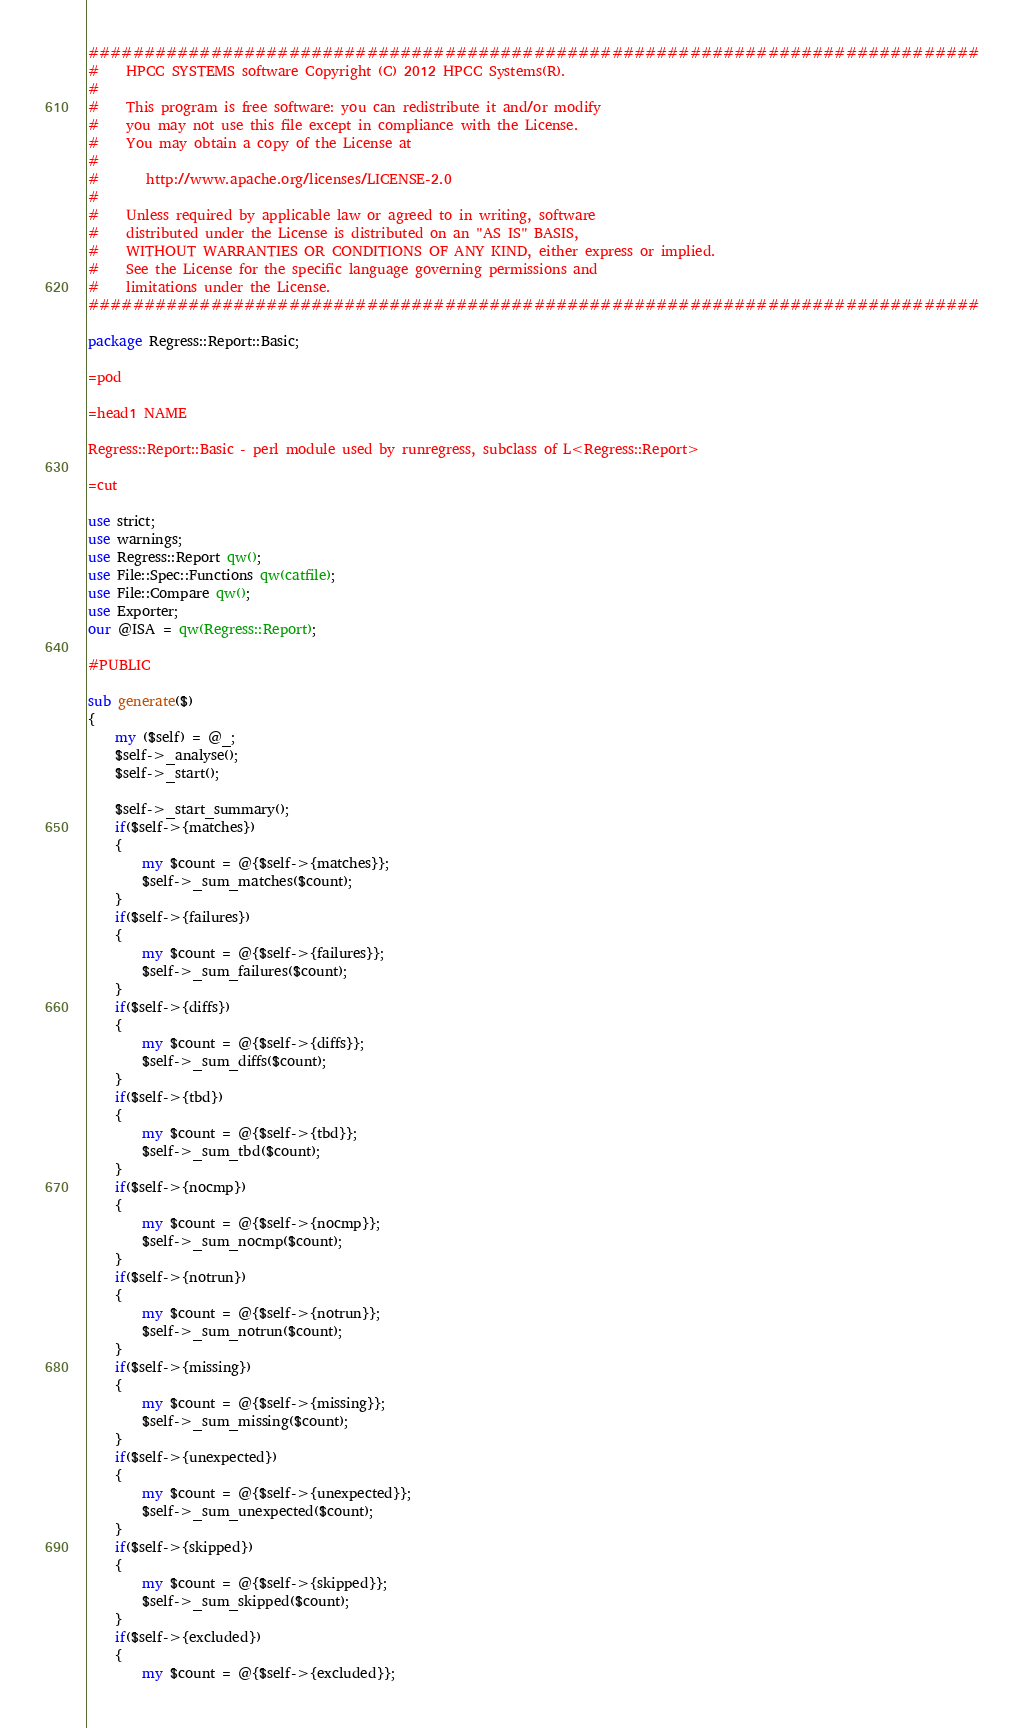<code> <loc_0><loc_0><loc_500><loc_500><_Perl_>################################################################################
#    HPCC SYSTEMS software Copyright (C) 2012 HPCC Systems(R).
#
#    This program is free software: you can redistribute it and/or modify
#    you may not use this file except in compliance with the License.
#    You may obtain a copy of the License at
#
#       http://www.apache.org/licenses/LICENSE-2.0
#
#    Unless required by applicable law or agreed to in writing, software
#    distributed under the License is distributed on an "AS IS" BASIS,
#    WITHOUT WARRANTIES OR CONDITIONS OF ANY KIND, either express or implied.
#    See the License for the specific language governing permissions and
#    limitations under the License.
################################################################################

package Regress::Report::Basic;

=pod

=head1 NAME
    
Regress::Report::Basic - perl module used by runregress, subclass of L<Regress::Report>

=cut

use strict;
use warnings;
use Regress::Report qw();
use File::Spec::Functions qw(catfile);
use File::Compare qw();
use Exporter;
our @ISA = qw(Regress::Report);

#PUBLIC

sub generate($)
{
    my ($self) = @_;
    $self->_analyse();
    $self->_start();

    $self->_start_summary();
    if($self->{matches})
    {
        my $count = @{$self->{matches}};
        $self->_sum_matches($count);
    }
    if($self->{failures})
    {
        my $count = @{$self->{failures}};
        $self->_sum_failures($count);
    }
    if($self->{diffs})
    {
        my $count = @{$self->{diffs}};
        $self->_sum_diffs($count);
    }
    if($self->{tbd})
    {
        my $count = @{$self->{tbd}};
        $self->_sum_tbd($count);
    }
    if($self->{nocmp})
    {
        my $count = @{$self->{nocmp}};
        $self->_sum_nocmp($count);
    }
    if($self->{notrun})
    {
        my $count = @{$self->{notrun}};
        $self->_sum_notrun($count);
    }
    if($self->{missing})
    {
        my $count = @{$self->{missing}};
        $self->_sum_missing($count);
    }
    if($self->{unexpected})
    {
        my $count = @{$self->{unexpected}};
        $self->_sum_unexpected($count);
    }
    if($self->{skipped})
    {
        my $count = @{$self->{skipped}};
        $self->_sum_skipped($count);
    }
    if($self->{excluded})
    {
        my $count = @{$self->{excluded}};</code> 